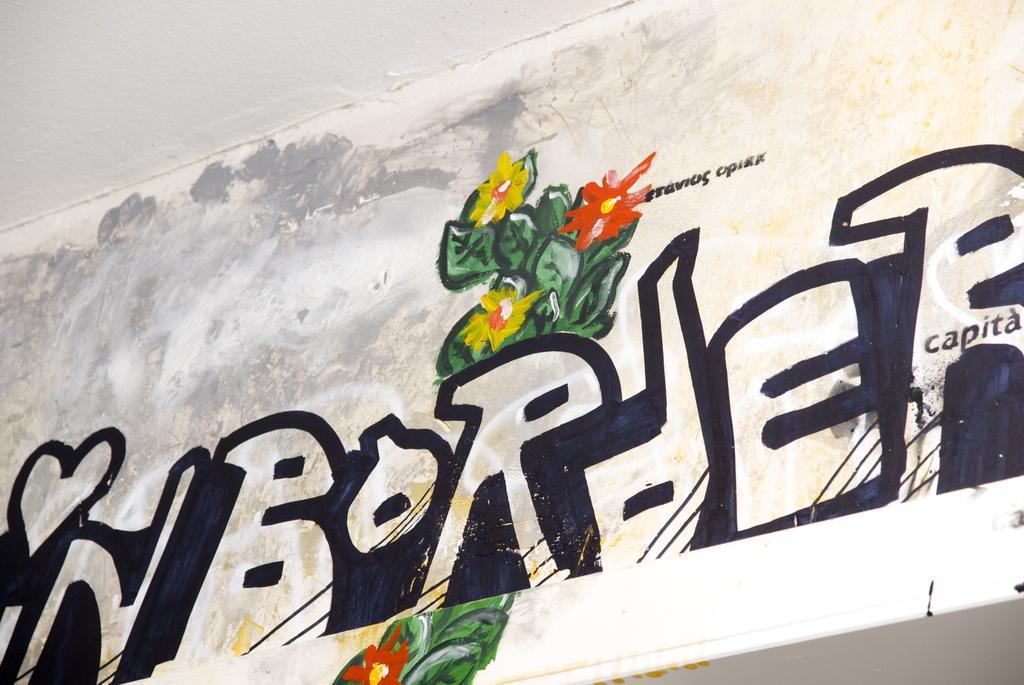Describe this image in one or two sentences. In this image I can see some text and painting on the wall. 